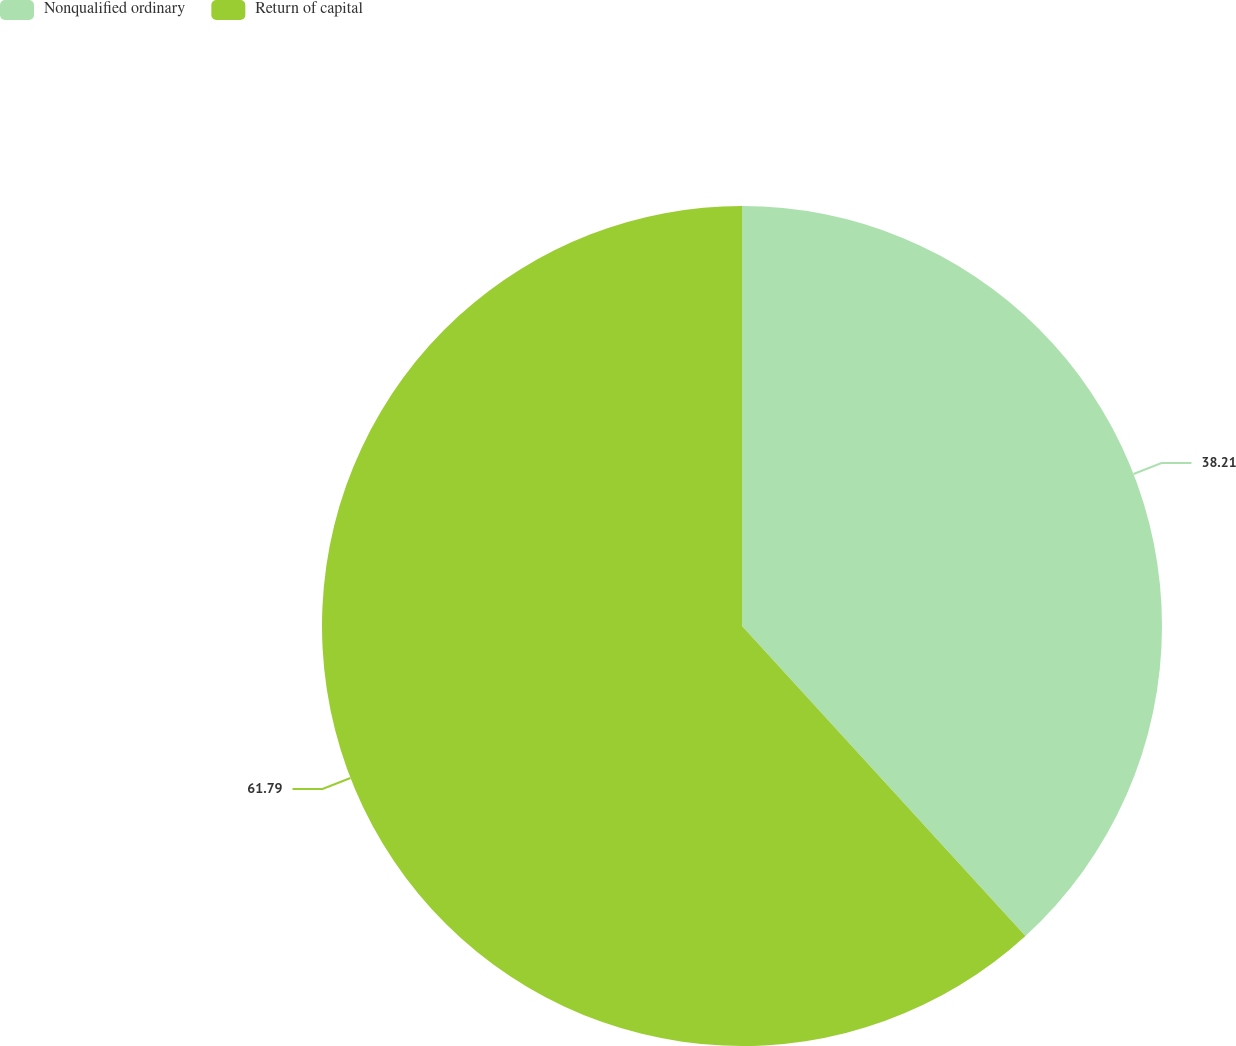Convert chart. <chart><loc_0><loc_0><loc_500><loc_500><pie_chart><fcel>Nonqualified ordinary<fcel>Return of capital<nl><fcel>38.21%<fcel>61.79%<nl></chart> 